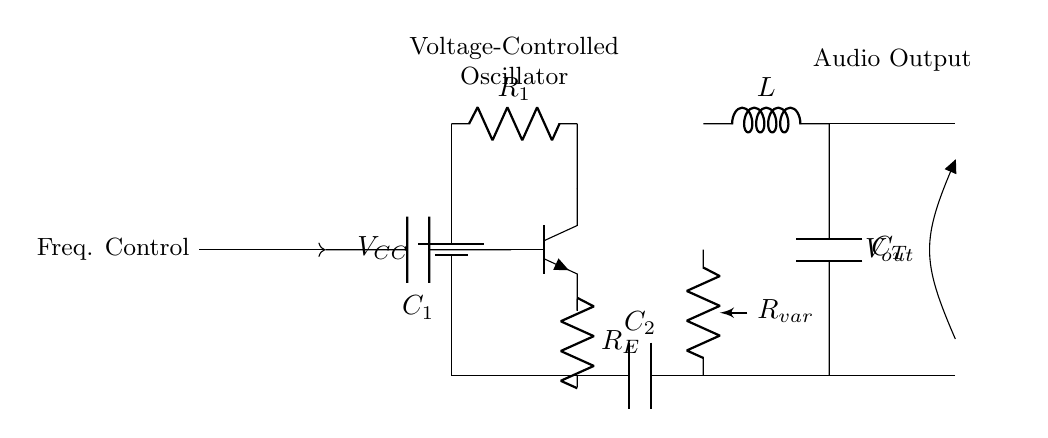What is the primary function of the circuit? The primary function of the circuit is to serve as a voltage-controlled oscillator, which generates audio signals. This is indicated by the label in the circuit diagram.
Answer: Voltage-controlled oscillator How many capacitors are present in the circuit? The circuit contains two capacitors, one labeled C1 and the other C2. These components are visually represented in the diagram, and both are crucial for the oscillator's frequency control.
Answer: Two What component modifies the frequency of the oscillator? The variable resistor, labeled Rvar, directly modifies the frequency of the oscillator by adjusting the resistance in the circuit. This affects the timing of the circuit and therefore its frequency output.
Answer: Variable resistor What type of output does this circuit produce? The output produced by this circuit is an audio output as indicated by the label at the output section connected to Vout. This audio output can be used for various sound effects in early film sound technology.
Answer: Audio output Which component provides the initial voltage for the circuit? The initial voltage is provided by the battery labeled Vcc which connects to the circuit and supplies the necessary voltage for operation.
Answer: Battery How does the LC tank circuit influence the output frequency? The LC tank circuit, consisting of an inductor labeled L and a capacitor labeled CT, forms a resonant circuit that determines the frequency of oscillation. The interaction between the inductor and capacitor sets the frequency at which the circuit operates.
Answer: Determines output frequency 